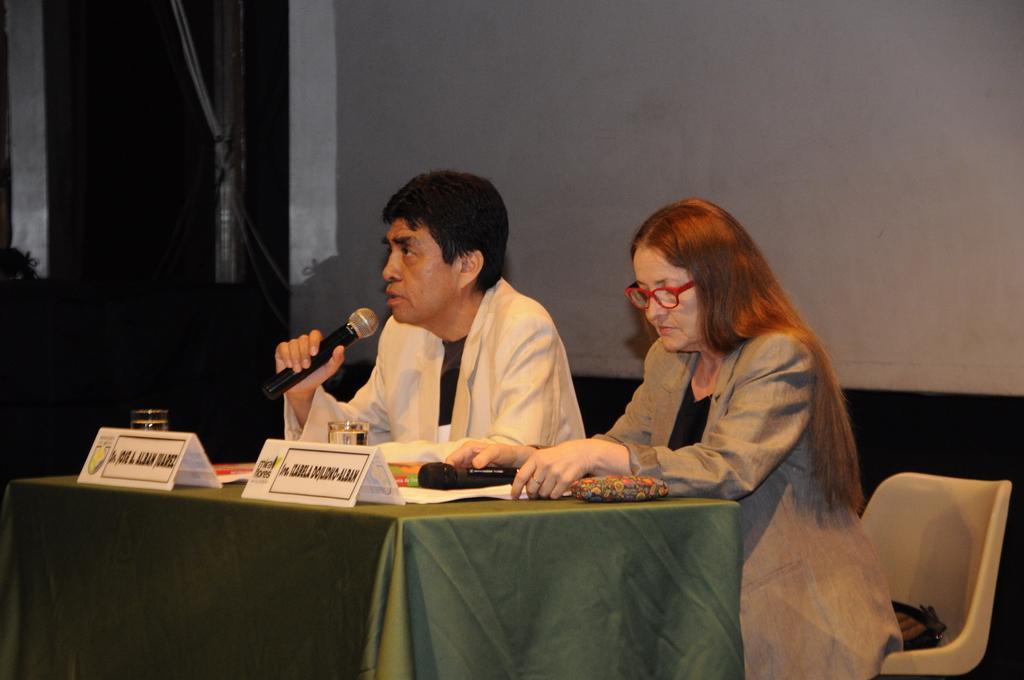Can you describe this image briefly? In the middle of the image two people are sitting on chairs and they are holding microphones. In front of them there is a table on the table there are some papers and glasses. Behind them there is a wall. 